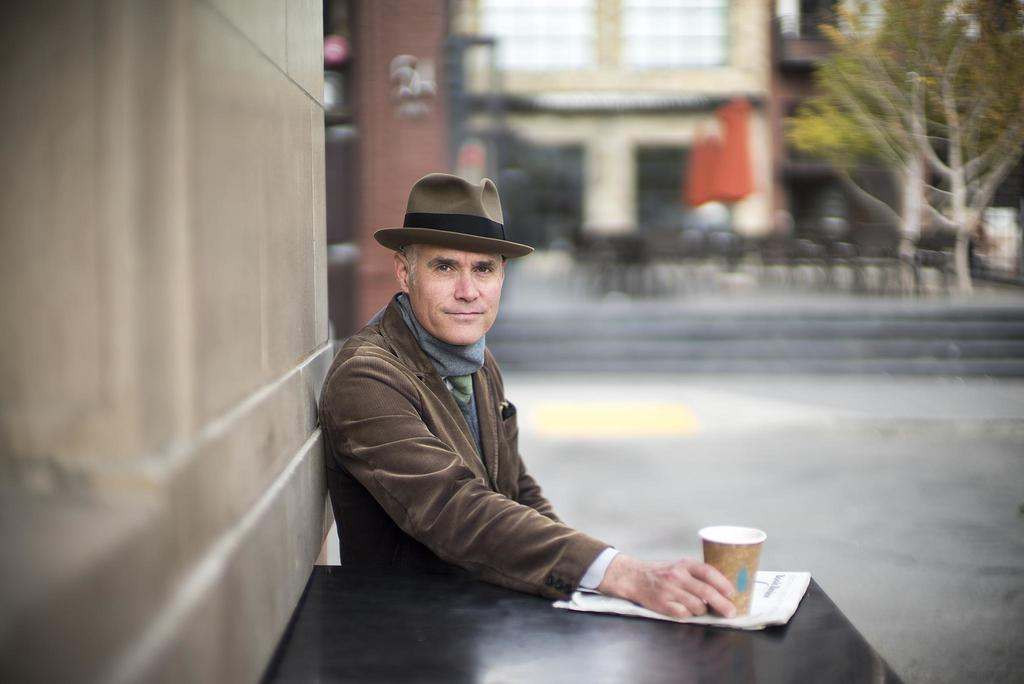Who or what is present in the image? There is a person in the image. What object can be seen near the person? There is a table in the image. What is on the table? There is a glass and a paper on the table. What can be seen in the background of the image? There are trees and buildings in the background of the image. What book is the person reading in the image? There is no book present in the image. Is the person depicted as a slave in the image? The image does not depict any form of slavery or servitude; it simply shows a person, a table, a glass, a paper, trees, and buildings in the background. 